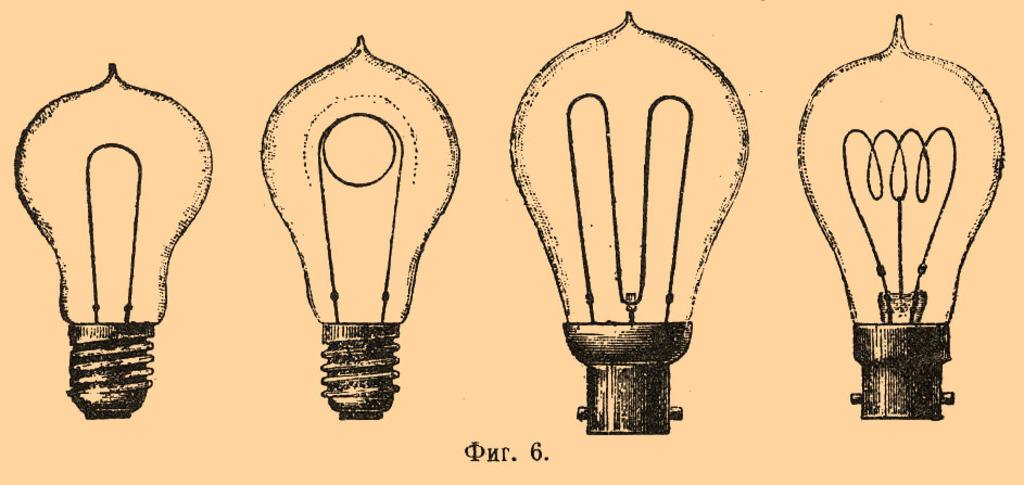What is depicted in the paintings in the image? There are paintings of a bulb in the image. What type of coastline can be seen in the image? There is no coastline present in the image; it features paintings of a bulb. What type of paper is used for the paintings in the image? The fact provided does not mention the type of paper used for the paintings, so we cannot determine that information from the image. 